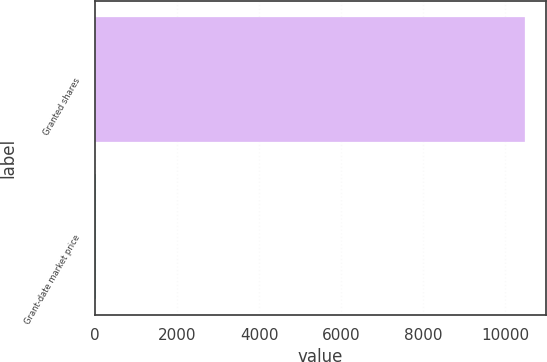<chart> <loc_0><loc_0><loc_500><loc_500><bar_chart><fcel>Granted shares<fcel>Grant-date market price<nl><fcel>10481<fcel>19.1<nl></chart> 